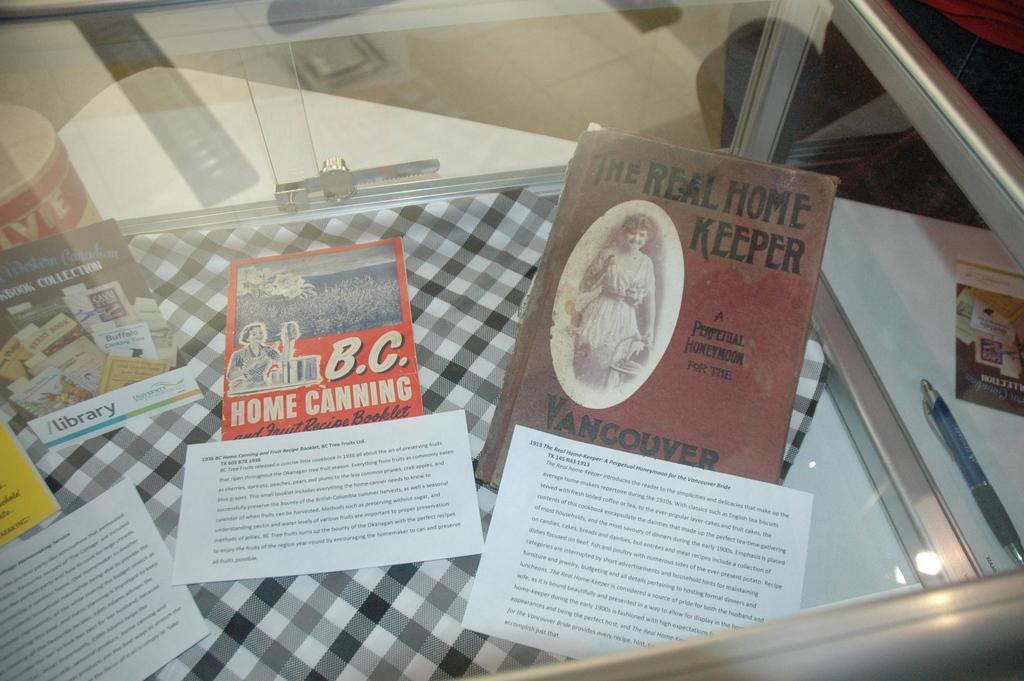<image>
Relay a brief, clear account of the picture shown. Several books on display like Home Canning and The Real Home Keeper 